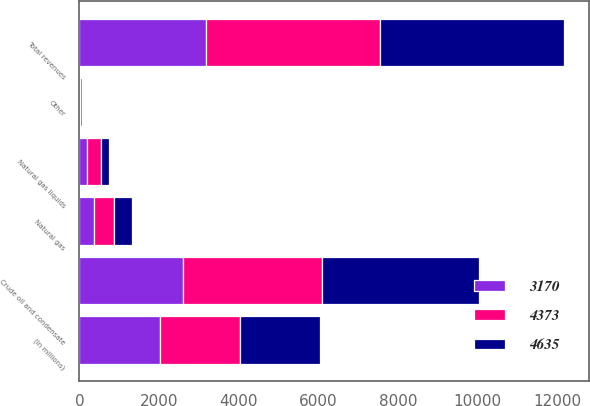Convert chart. <chart><loc_0><loc_0><loc_500><loc_500><stacked_bar_chart><ecel><fcel>(In millions)<fcel>Crude oil and condensate<fcel>Natural gas liquids<fcel>Natural gas<fcel>Other<fcel>Total revenues<nl><fcel>4373<fcel>2017<fcel>3477<fcel>338<fcel>510<fcel>48<fcel>4373<nl><fcel>3170<fcel>2016<fcel>2605<fcel>198<fcel>356<fcel>11<fcel>3170<nl><fcel>4635<fcel>2015<fcel>3963<fcel>203<fcel>464<fcel>5<fcel>4635<nl></chart> 